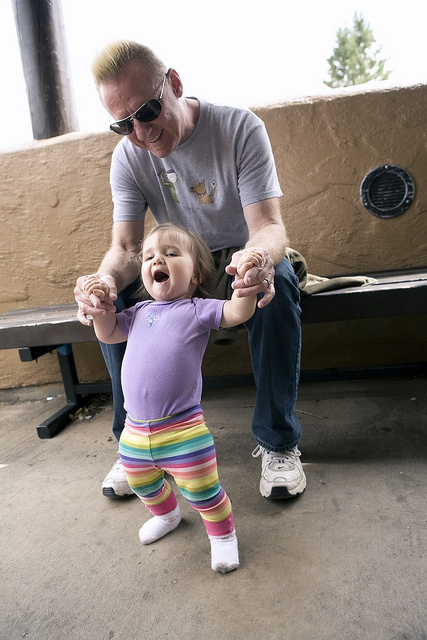Describe the objects in this image and their specific colors. I can see people in white, gray, black, lightgray, and darkgray tones, people in white, lavender, gray, brown, and darkgray tones, and bench in white, black, gray, lightgray, and darkgray tones in this image. 